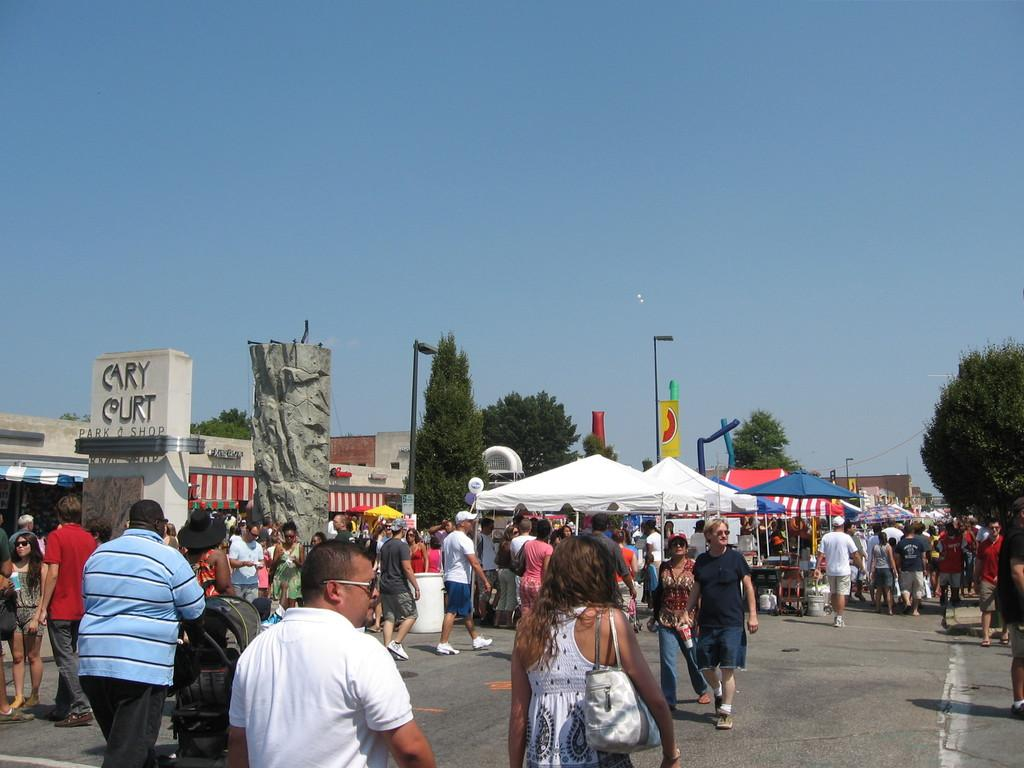What are the people in the image doing? There are many people walking on the road in the image. What else can be seen in the image besides the people? There are stalls, trees, and a light pole in the image. What is visible at the top of the image? The sky is visible at the top of the image. What type of pest is being managed by the person in the image? There is no person managing a pest in the image; it features people walking on the road and other elements. Can you tell me where the gun is located in the image? There is no gun present in the image. 